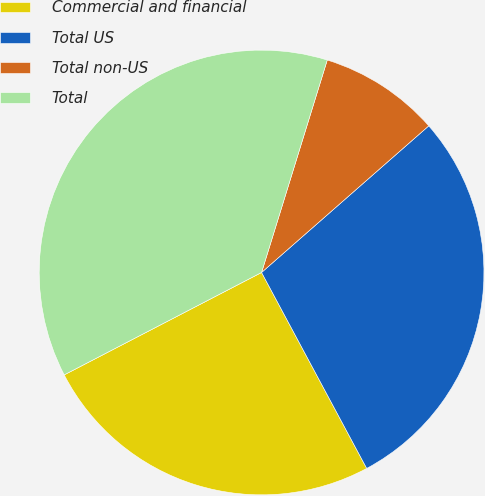Convert chart. <chart><loc_0><loc_0><loc_500><loc_500><pie_chart><fcel>Commercial and financial<fcel>Total US<fcel>Total non-US<fcel>Total<nl><fcel>25.22%<fcel>28.62%<fcel>8.77%<fcel>37.39%<nl></chart> 